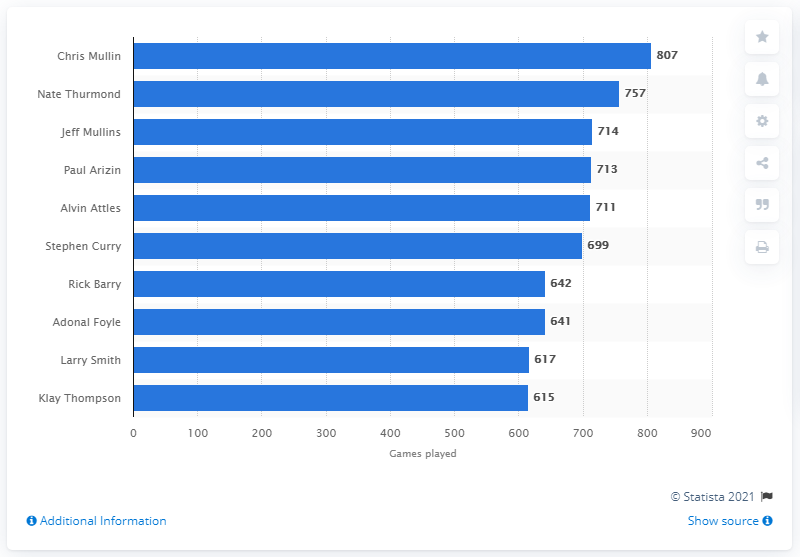Outline some significant characteristics in this image. Chris Mullin has played 807 games. Chris Mullin is the career games played leader of the Golden State Warriors. 